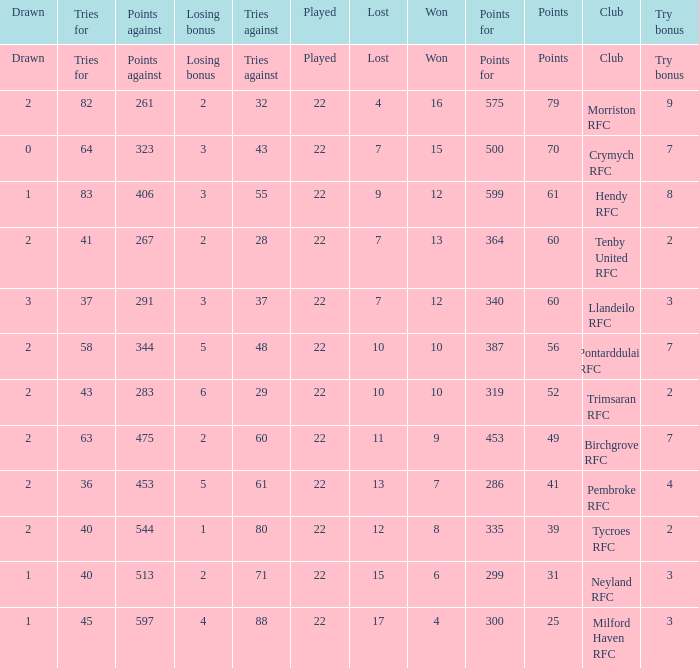What's the won with try bonus being 8 12.0. 